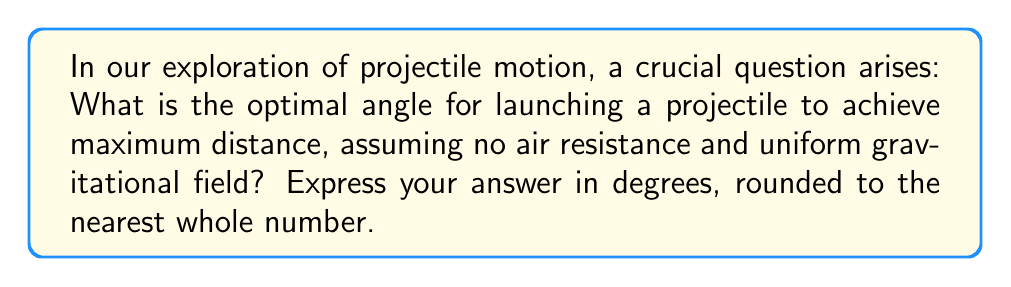Could you help me with this problem? Let's approach this step-by-step:

1) The range (R) of a projectile launched with initial velocity $v_0$ at an angle $\theta$ to the horizontal is given by:

   $$R = \frac{v_0^2 \sin(2\theta)}{g}$$

   Where $g$ is the acceleration due to gravity.

2) To find the maximum range, we need to maximize $\sin(2\theta)$. 

3) The sine function reaches its maximum value of 1 when its argument is 90°.

4) So, we want:

   $$2\theta = 90°$$

5) Solving for $\theta$:

   $$\theta = 45°$$

6) This result is independent of the initial velocity and the gravitational acceleration, making it universally applicable on Earth and other planets with uniform gravitational fields.

7) The physical interpretation: at 45°, we have an equal balance between the horizontal distance traveled and the time of flight. Any angle less than 45° reduces time of flight, while any angle greater than 45° reduces horizontal velocity.

8) Rounding to the nearest whole number isn't necessary here as 45° is already a whole number.
Answer: 45° 